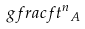<formula> <loc_0><loc_0><loc_500><loc_500>\ g f r a c { f } { t ^ { n } } _ { A }</formula> 